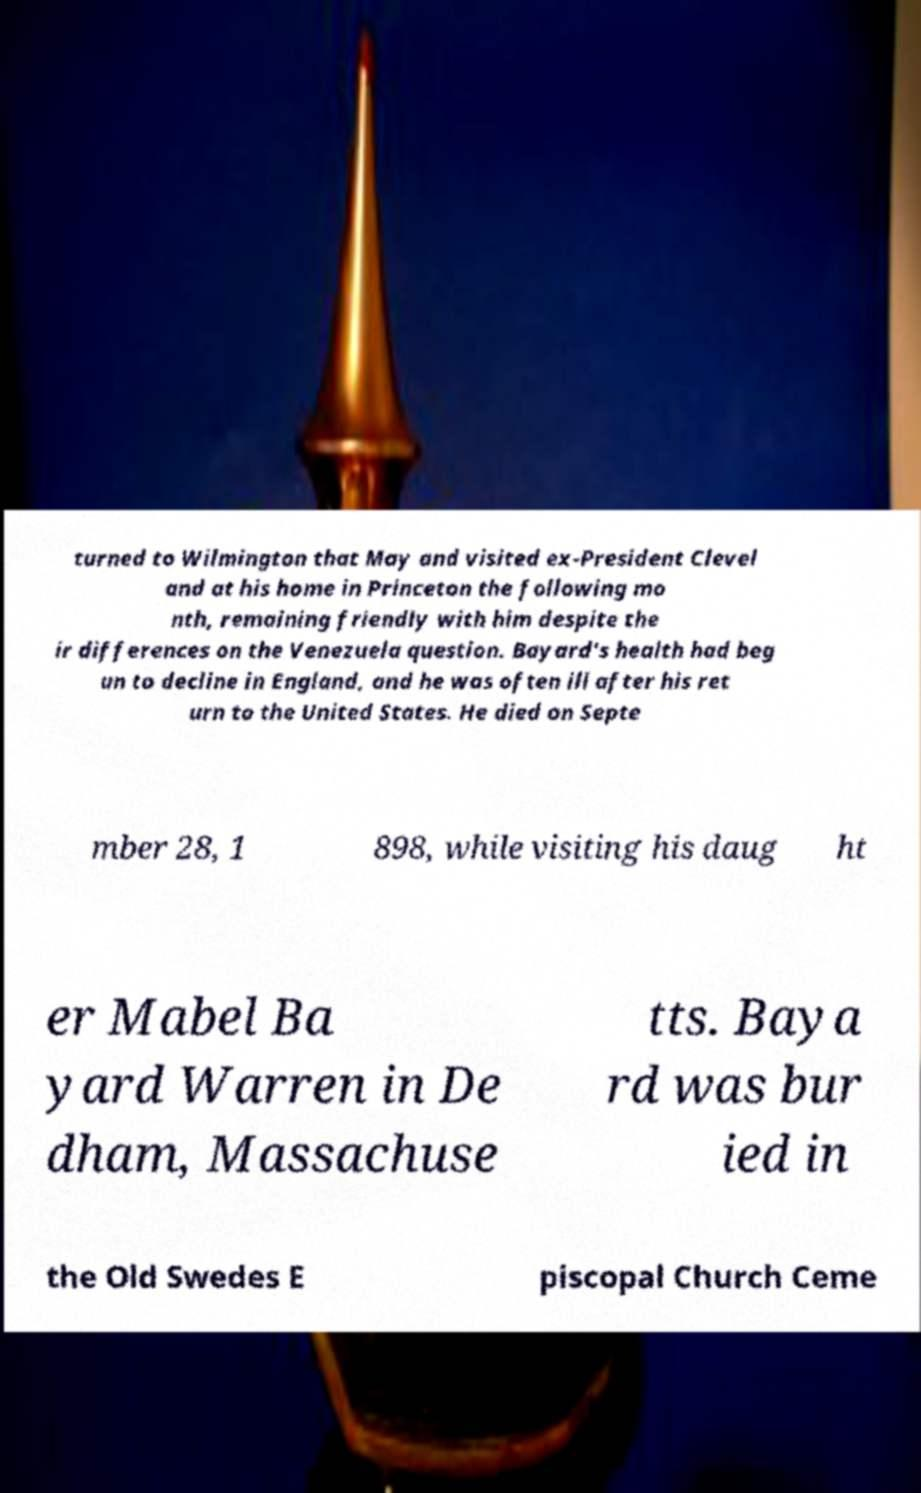I need the written content from this picture converted into text. Can you do that? turned to Wilmington that May and visited ex-President Clevel and at his home in Princeton the following mo nth, remaining friendly with him despite the ir differences on the Venezuela question. Bayard's health had beg un to decline in England, and he was often ill after his ret urn to the United States. He died on Septe mber 28, 1 898, while visiting his daug ht er Mabel Ba yard Warren in De dham, Massachuse tts. Baya rd was bur ied in the Old Swedes E piscopal Church Ceme 